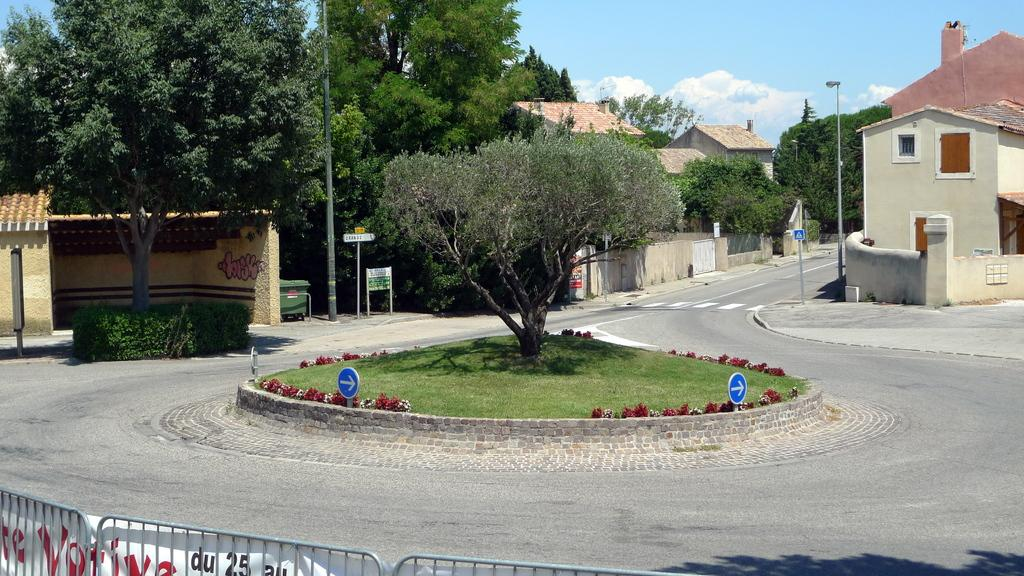What can be seen at the bottom of the image? There is a boundary at the bottom side of the image. What is located in the center of the image? There are houses and trees in the center of the image. What type of alarm can be heard going off in the image? There is no alarm present in the image, and therefore no such sound can be heard. What color is the sock on the tree in the image? There is no sock present in the image; it only features houses and trees. 